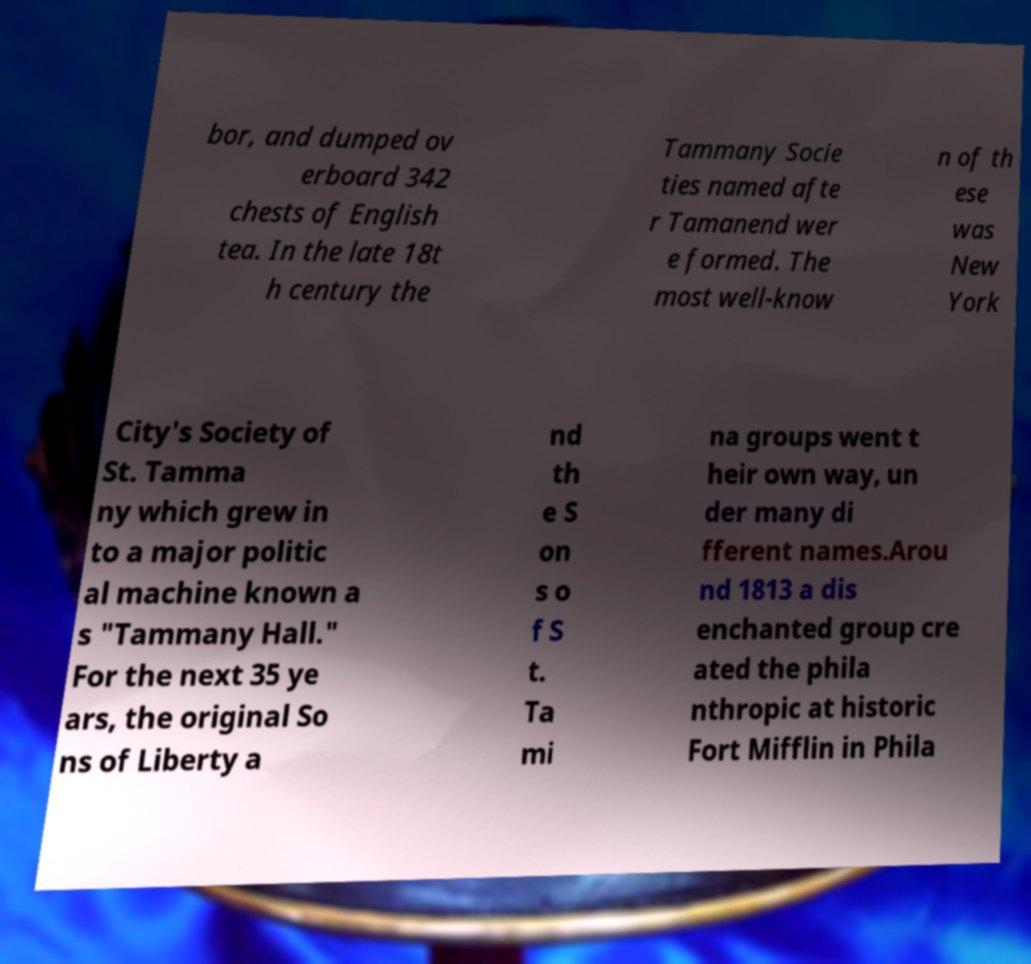There's text embedded in this image that I need extracted. Can you transcribe it verbatim? bor, and dumped ov erboard 342 chests of English tea. In the late 18t h century the Tammany Socie ties named afte r Tamanend wer e formed. The most well-know n of th ese was New York City's Society of St. Tamma ny which grew in to a major politic al machine known a s "Tammany Hall." For the next 35 ye ars, the original So ns of Liberty a nd th e S on s o f S t. Ta mi na groups went t heir own way, un der many di fferent names.Arou nd 1813 a dis enchanted group cre ated the phila nthropic at historic Fort Mifflin in Phila 